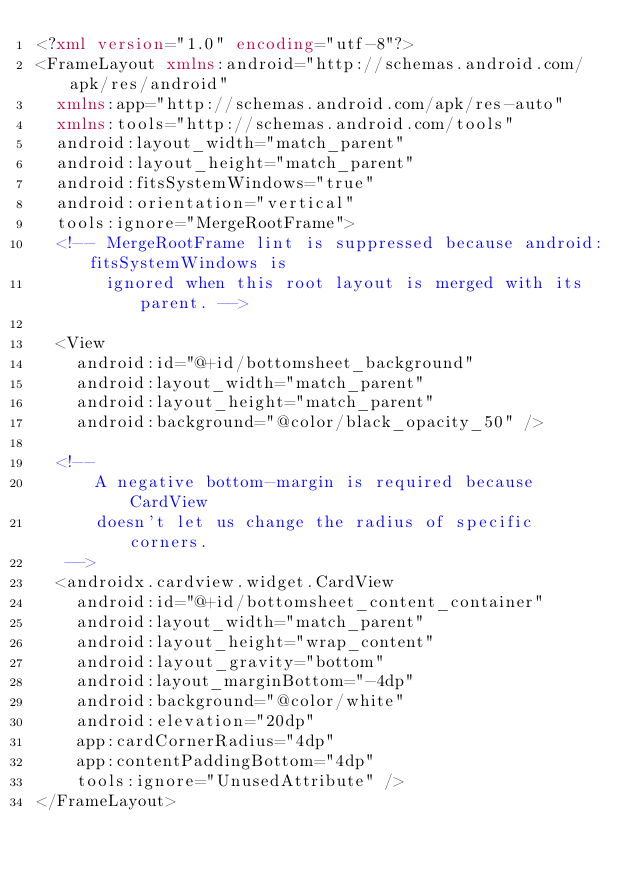Convert code to text. <code><loc_0><loc_0><loc_500><loc_500><_XML_><?xml version="1.0" encoding="utf-8"?>
<FrameLayout xmlns:android="http://schemas.android.com/apk/res/android"
  xmlns:app="http://schemas.android.com/apk/res-auto"
  xmlns:tools="http://schemas.android.com/tools"
  android:layout_width="match_parent"
  android:layout_height="match_parent"
  android:fitsSystemWindows="true"
  android:orientation="vertical"
  tools:ignore="MergeRootFrame">
  <!-- MergeRootFrame lint is suppressed because android:fitsSystemWindows is
       ignored when this root layout is merged with its parent. -->

  <View
    android:id="@+id/bottomsheet_background"
    android:layout_width="match_parent"
    android:layout_height="match_parent"
    android:background="@color/black_opacity_50" />

  <!--
      A negative bottom-margin is required because CardView
      doesn't let us change the radius of specific corners.
   -->
  <androidx.cardview.widget.CardView
    android:id="@+id/bottomsheet_content_container"
    android:layout_width="match_parent"
    android:layout_height="wrap_content"
    android:layout_gravity="bottom"
    android:layout_marginBottom="-4dp"
    android:background="@color/white"
    android:elevation="20dp"
    app:cardCornerRadius="4dp"
    app:contentPaddingBottom="4dp"
    tools:ignore="UnusedAttribute" />
</FrameLayout>
</code> 